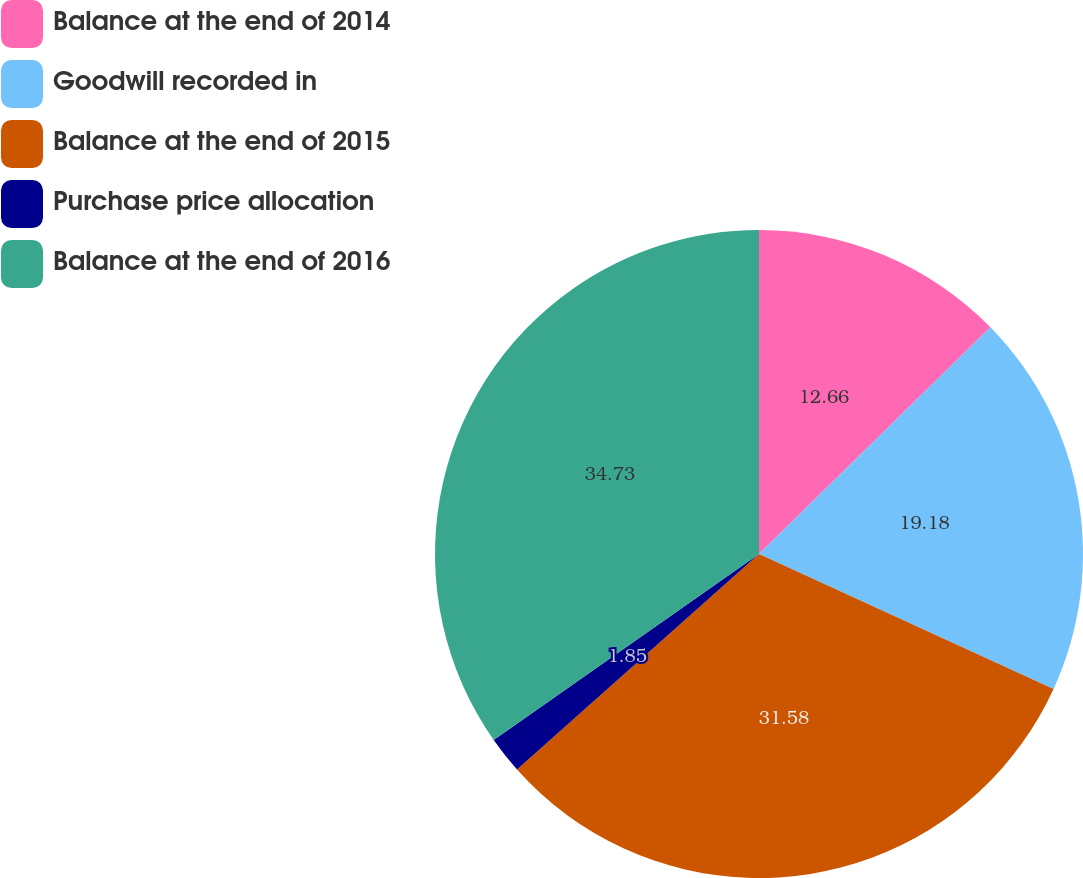Convert chart. <chart><loc_0><loc_0><loc_500><loc_500><pie_chart><fcel>Balance at the end of 2014<fcel>Goodwill recorded in<fcel>Balance at the end of 2015<fcel>Purchase price allocation<fcel>Balance at the end of 2016<nl><fcel>12.66%<fcel>19.18%<fcel>31.58%<fcel>1.85%<fcel>34.73%<nl></chart> 